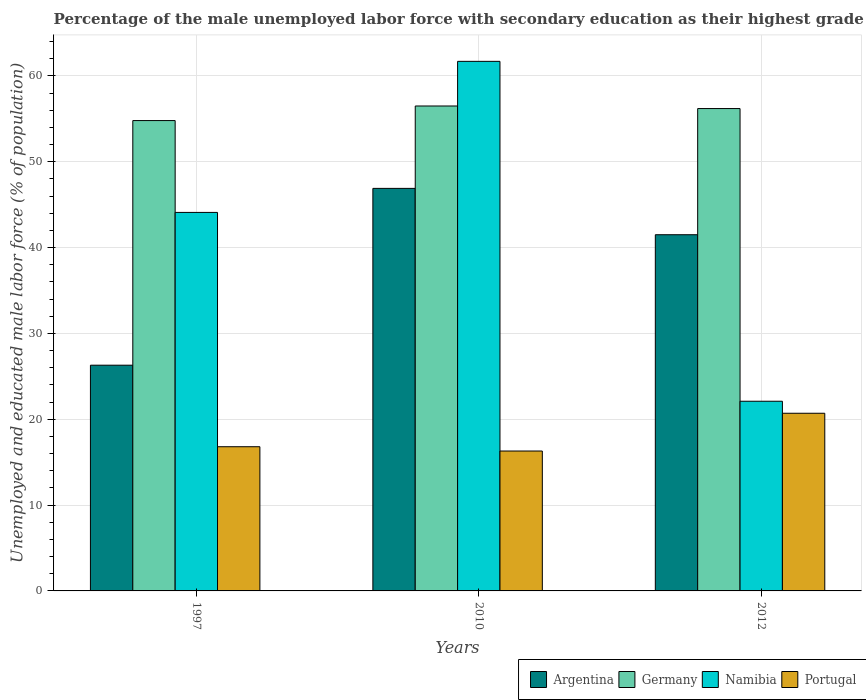How many different coloured bars are there?
Keep it short and to the point. 4. What is the label of the 1st group of bars from the left?
Provide a short and direct response. 1997. In how many cases, is the number of bars for a given year not equal to the number of legend labels?
Your answer should be compact. 0. What is the percentage of the unemployed male labor force with secondary education in Portugal in 2010?
Provide a succinct answer. 16.3. Across all years, what is the maximum percentage of the unemployed male labor force with secondary education in Portugal?
Offer a terse response. 20.7. Across all years, what is the minimum percentage of the unemployed male labor force with secondary education in Portugal?
Offer a very short reply. 16.3. In which year was the percentage of the unemployed male labor force with secondary education in Namibia maximum?
Your response must be concise. 2010. What is the total percentage of the unemployed male labor force with secondary education in Argentina in the graph?
Give a very brief answer. 114.7. What is the difference between the percentage of the unemployed male labor force with secondary education in Argentina in 1997 and that in 2010?
Offer a terse response. -20.6. What is the difference between the percentage of the unemployed male labor force with secondary education in Portugal in 2010 and the percentage of the unemployed male labor force with secondary education in Argentina in 2012?
Make the answer very short. -25.2. What is the average percentage of the unemployed male labor force with secondary education in Namibia per year?
Keep it short and to the point. 42.63. In the year 1997, what is the difference between the percentage of the unemployed male labor force with secondary education in Portugal and percentage of the unemployed male labor force with secondary education in Germany?
Your answer should be very brief. -38. In how many years, is the percentage of the unemployed male labor force with secondary education in Argentina greater than 12 %?
Offer a very short reply. 3. What is the ratio of the percentage of the unemployed male labor force with secondary education in Germany in 1997 to that in 2012?
Provide a short and direct response. 0.98. Is the percentage of the unemployed male labor force with secondary education in Argentina in 1997 less than that in 2010?
Your answer should be very brief. Yes. What is the difference between the highest and the second highest percentage of the unemployed male labor force with secondary education in Portugal?
Give a very brief answer. 3.9. What is the difference between the highest and the lowest percentage of the unemployed male labor force with secondary education in Portugal?
Keep it short and to the point. 4.4. Is the sum of the percentage of the unemployed male labor force with secondary education in Portugal in 1997 and 2010 greater than the maximum percentage of the unemployed male labor force with secondary education in Argentina across all years?
Your answer should be compact. No. How many bars are there?
Make the answer very short. 12. Are all the bars in the graph horizontal?
Provide a short and direct response. No. How many years are there in the graph?
Offer a very short reply. 3. What is the difference between two consecutive major ticks on the Y-axis?
Your response must be concise. 10. Are the values on the major ticks of Y-axis written in scientific E-notation?
Your response must be concise. No. Does the graph contain grids?
Keep it short and to the point. Yes. How are the legend labels stacked?
Your answer should be compact. Horizontal. What is the title of the graph?
Your answer should be very brief. Percentage of the male unemployed labor force with secondary education as their highest grade. What is the label or title of the X-axis?
Provide a succinct answer. Years. What is the label or title of the Y-axis?
Your response must be concise. Unemployed and educated male labor force (% of population). What is the Unemployed and educated male labor force (% of population) in Argentina in 1997?
Your response must be concise. 26.3. What is the Unemployed and educated male labor force (% of population) in Germany in 1997?
Offer a terse response. 54.8. What is the Unemployed and educated male labor force (% of population) in Namibia in 1997?
Make the answer very short. 44.1. What is the Unemployed and educated male labor force (% of population) of Portugal in 1997?
Your answer should be very brief. 16.8. What is the Unemployed and educated male labor force (% of population) in Argentina in 2010?
Make the answer very short. 46.9. What is the Unemployed and educated male labor force (% of population) of Germany in 2010?
Provide a succinct answer. 56.5. What is the Unemployed and educated male labor force (% of population) of Namibia in 2010?
Offer a terse response. 61.7. What is the Unemployed and educated male labor force (% of population) of Portugal in 2010?
Offer a terse response. 16.3. What is the Unemployed and educated male labor force (% of population) in Argentina in 2012?
Make the answer very short. 41.5. What is the Unemployed and educated male labor force (% of population) of Germany in 2012?
Offer a very short reply. 56.2. What is the Unemployed and educated male labor force (% of population) of Namibia in 2012?
Provide a short and direct response. 22.1. What is the Unemployed and educated male labor force (% of population) of Portugal in 2012?
Make the answer very short. 20.7. Across all years, what is the maximum Unemployed and educated male labor force (% of population) of Argentina?
Ensure brevity in your answer.  46.9. Across all years, what is the maximum Unemployed and educated male labor force (% of population) in Germany?
Provide a short and direct response. 56.5. Across all years, what is the maximum Unemployed and educated male labor force (% of population) in Namibia?
Provide a succinct answer. 61.7. Across all years, what is the maximum Unemployed and educated male labor force (% of population) in Portugal?
Give a very brief answer. 20.7. Across all years, what is the minimum Unemployed and educated male labor force (% of population) of Argentina?
Offer a terse response. 26.3. Across all years, what is the minimum Unemployed and educated male labor force (% of population) in Germany?
Ensure brevity in your answer.  54.8. Across all years, what is the minimum Unemployed and educated male labor force (% of population) in Namibia?
Provide a succinct answer. 22.1. Across all years, what is the minimum Unemployed and educated male labor force (% of population) in Portugal?
Provide a succinct answer. 16.3. What is the total Unemployed and educated male labor force (% of population) in Argentina in the graph?
Keep it short and to the point. 114.7. What is the total Unemployed and educated male labor force (% of population) in Germany in the graph?
Give a very brief answer. 167.5. What is the total Unemployed and educated male labor force (% of population) in Namibia in the graph?
Keep it short and to the point. 127.9. What is the total Unemployed and educated male labor force (% of population) of Portugal in the graph?
Offer a terse response. 53.8. What is the difference between the Unemployed and educated male labor force (% of population) in Argentina in 1997 and that in 2010?
Give a very brief answer. -20.6. What is the difference between the Unemployed and educated male labor force (% of population) of Namibia in 1997 and that in 2010?
Provide a short and direct response. -17.6. What is the difference between the Unemployed and educated male labor force (% of population) in Portugal in 1997 and that in 2010?
Provide a short and direct response. 0.5. What is the difference between the Unemployed and educated male labor force (% of population) in Argentina in 1997 and that in 2012?
Your answer should be compact. -15.2. What is the difference between the Unemployed and educated male labor force (% of population) in Portugal in 1997 and that in 2012?
Ensure brevity in your answer.  -3.9. What is the difference between the Unemployed and educated male labor force (% of population) of Germany in 2010 and that in 2012?
Your response must be concise. 0.3. What is the difference between the Unemployed and educated male labor force (% of population) of Namibia in 2010 and that in 2012?
Provide a succinct answer. 39.6. What is the difference between the Unemployed and educated male labor force (% of population) of Argentina in 1997 and the Unemployed and educated male labor force (% of population) of Germany in 2010?
Offer a terse response. -30.2. What is the difference between the Unemployed and educated male labor force (% of population) of Argentina in 1997 and the Unemployed and educated male labor force (% of population) of Namibia in 2010?
Give a very brief answer. -35.4. What is the difference between the Unemployed and educated male labor force (% of population) of Germany in 1997 and the Unemployed and educated male labor force (% of population) of Portugal in 2010?
Offer a very short reply. 38.5. What is the difference between the Unemployed and educated male labor force (% of population) of Namibia in 1997 and the Unemployed and educated male labor force (% of population) of Portugal in 2010?
Ensure brevity in your answer.  27.8. What is the difference between the Unemployed and educated male labor force (% of population) in Argentina in 1997 and the Unemployed and educated male labor force (% of population) in Germany in 2012?
Ensure brevity in your answer.  -29.9. What is the difference between the Unemployed and educated male labor force (% of population) of Argentina in 1997 and the Unemployed and educated male labor force (% of population) of Portugal in 2012?
Your response must be concise. 5.6. What is the difference between the Unemployed and educated male labor force (% of population) in Germany in 1997 and the Unemployed and educated male labor force (% of population) in Namibia in 2012?
Give a very brief answer. 32.7. What is the difference between the Unemployed and educated male labor force (% of population) of Germany in 1997 and the Unemployed and educated male labor force (% of population) of Portugal in 2012?
Give a very brief answer. 34.1. What is the difference between the Unemployed and educated male labor force (% of population) of Namibia in 1997 and the Unemployed and educated male labor force (% of population) of Portugal in 2012?
Give a very brief answer. 23.4. What is the difference between the Unemployed and educated male labor force (% of population) of Argentina in 2010 and the Unemployed and educated male labor force (% of population) of Namibia in 2012?
Your answer should be very brief. 24.8. What is the difference between the Unemployed and educated male labor force (% of population) of Argentina in 2010 and the Unemployed and educated male labor force (% of population) of Portugal in 2012?
Ensure brevity in your answer.  26.2. What is the difference between the Unemployed and educated male labor force (% of population) in Germany in 2010 and the Unemployed and educated male labor force (% of population) in Namibia in 2012?
Offer a very short reply. 34.4. What is the difference between the Unemployed and educated male labor force (% of population) of Germany in 2010 and the Unemployed and educated male labor force (% of population) of Portugal in 2012?
Your answer should be compact. 35.8. What is the difference between the Unemployed and educated male labor force (% of population) of Namibia in 2010 and the Unemployed and educated male labor force (% of population) of Portugal in 2012?
Your answer should be very brief. 41. What is the average Unemployed and educated male labor force (% of population) in Argentina per year?
Your answer should be very brief. 38.23. What is the average Unemployed and educated male labor force (% of population) in Germany per year?
Offer a terse response. 55.83. What is the average Unemployed and educated male labor force (% of population) of Namibia per year?
Make the answer very short. 42.63. What is the average Unemployed and educated male labor force (% of population) in Portugal per year?
Give a very brief answer. 17.93. In the year 1997, what is the difference between the Unemployed and educated male labor force (% of population) of Argentina and Unemployed and educated male labor force (% of population) of Germany?
Keep it short and to the point. -28.5. In the year 1997, what is the difference between the Unemployed and educated male labor force (% of population) in Argentina and Unemployed and educated male labor force (% of population) in Namibia?
Keep it short and to the point. -17.8. In the year 1997, what is the difference between the Unemployed and educated male labor force (% of population) in Germany and Unemployed and educated male labor force (% of population) in Portugal?
Your answer should be compact. 38. In the year 1997, what is the difference between the Unemployed and educated male labor force (% of population) in Namibia and Unemployed and educated male labor force (% of population) in Portugal?
Give a very brief answer. 27.3. In the year 2010, what is the difference between the Unemployed and educated male labor force (% of population) of Argentina and Unemployed and educated male labor force (% of population) of Germany?
Offer a very short reply. -9.6. In the year 2010, what is the difference between the Unemployed and educated male labor force (% of population) in Argentina and Unemployed and educated male labor force (% of population) in Namibia?
Ensure brevity in your answer.  -14.8. In the year 2010, what is the difference between the Unemployed and educated male labor force (% of population) of Argentina and Unemployed and educated male labor force (% of population) of Portugal?
Offer a very short reply. 30.6. In the year 2010, what is the difference between the Unemployed and educated male labor force (% of population) of Germany and Unemployed and educated male labor force (% of population) of Portugal?
Offer a very short reply. 40.2. In the year 2010, what is the difference between the Unemployed and educated male labor force (% of population) of Namibia and Unemployed and educated male labor force (% of population) of Portugal?
Give a very brief answer. 45.4. In the year 2012, what is the difference between the Unemployed and educated male labor force (% of population) in Argentina and Unemployed and educated male labor force (% of population) in Germany?
Provide a succinct answer. -14.7. In the year 2012, what is the difference between the Unemployed and educated male labor force (% of population) in Argentina and Unemployed and educated male labor force (% of population) in Portugal?
Your answer should be very brief. 20.8. In the year 2012, what is the difference between the Unemployed and educated male labor force (% of population) of Germany and Unemployed and educated male labor force (% of population) of Namibia?
Provide a succinct answer. 34.1. In the year 2012, what is the difference between the Unemployed and educated male labor force (% of population) in Germany and Unemployed and educated male labor force (% of population) in Portugal?
Your answer should be compact. 35.5. What is the ratio of the Unemployed and educated male labor force (% of population) in Argentina in 1997 to that in 2010?
Offer a very short reply. 0.56. What is the ratio of the Unemployed and educated male labor force (% of population) in Germany in 1997 to that in 2010?
Your response must be concise. 0.97. What is the ratio of the Unemployed and educated male labor force (% of population) of Namibia in 1997 to that in 2010?
Provide a short and direct response. 0.71. What is the ratio of the Unemployed and educated male labor force (% of population) in Portugal in 1997 to that in 2010?
Give a very brief answer. 1.03. What is the ratio of the Unemployed and educated male labor force (% of population) in Argentina in 1997 to that in 2012?
Ensure brevity in your answer.  0.63. What is the ratio of the Unemployed and educated male labor force (% of population) of Germany in 1997 to that in 2012?
Offer a very short reply. 0.98. What is the ratio of the Unemployed and educated male labor force (% of population) in Namibia in 1997 to that in 2012?
Ensure brevity in your answer.  2. What is the ratio of the Unemployed and educated male labor force (% of population) of Portugal in 1997 to that in 2012?
Provide a succinct answer. 0.81. What is the ratio of the Unemployed and educated male labor force (% of population) in Argentina in 2010 to that in 2012?
Your response must be concise. 1.13. What is the ratio of the Unemployed and educated male labor force (% of population) in Germany in 2010 to that in 2012?
Give a very brief answer. 1.01. What is the ratio of the Unemployed and educated male labor force (% of population) in Namibia in 2010 to that in 2012?
Make the answer very short. 2.79. What is the ratio of the Unemployed and educated male labor force (% of population) in Portugal in 2010 to that in 2012?
Give a very brief answer. 0.79. What is the difference between the highest and the second highest Unemployed and educated male labor force (% of population) of Germany?
Your answer should be very brief. 0.3. What is the difference between the highest and the second highest Unemployed and educated male labor force (% of population) in Namibia?
Ensure brevity in your answer.  17.6. What is the difference between the highest and the lowest Unemployed and educated male labor force (% of population) in Argentina?
Your response must be concise. 20.6. What is the difference between the highest and the lowest Unemployed and educated male labor force (% of population) of Namibia?
Provide a succinct answer. 39.6. 